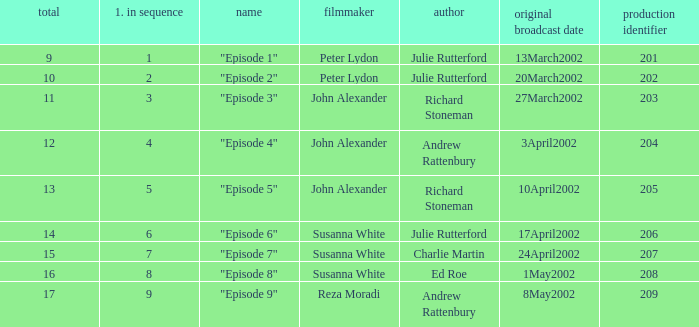When "episode 1" is the title what is the overall number? 9.0. 